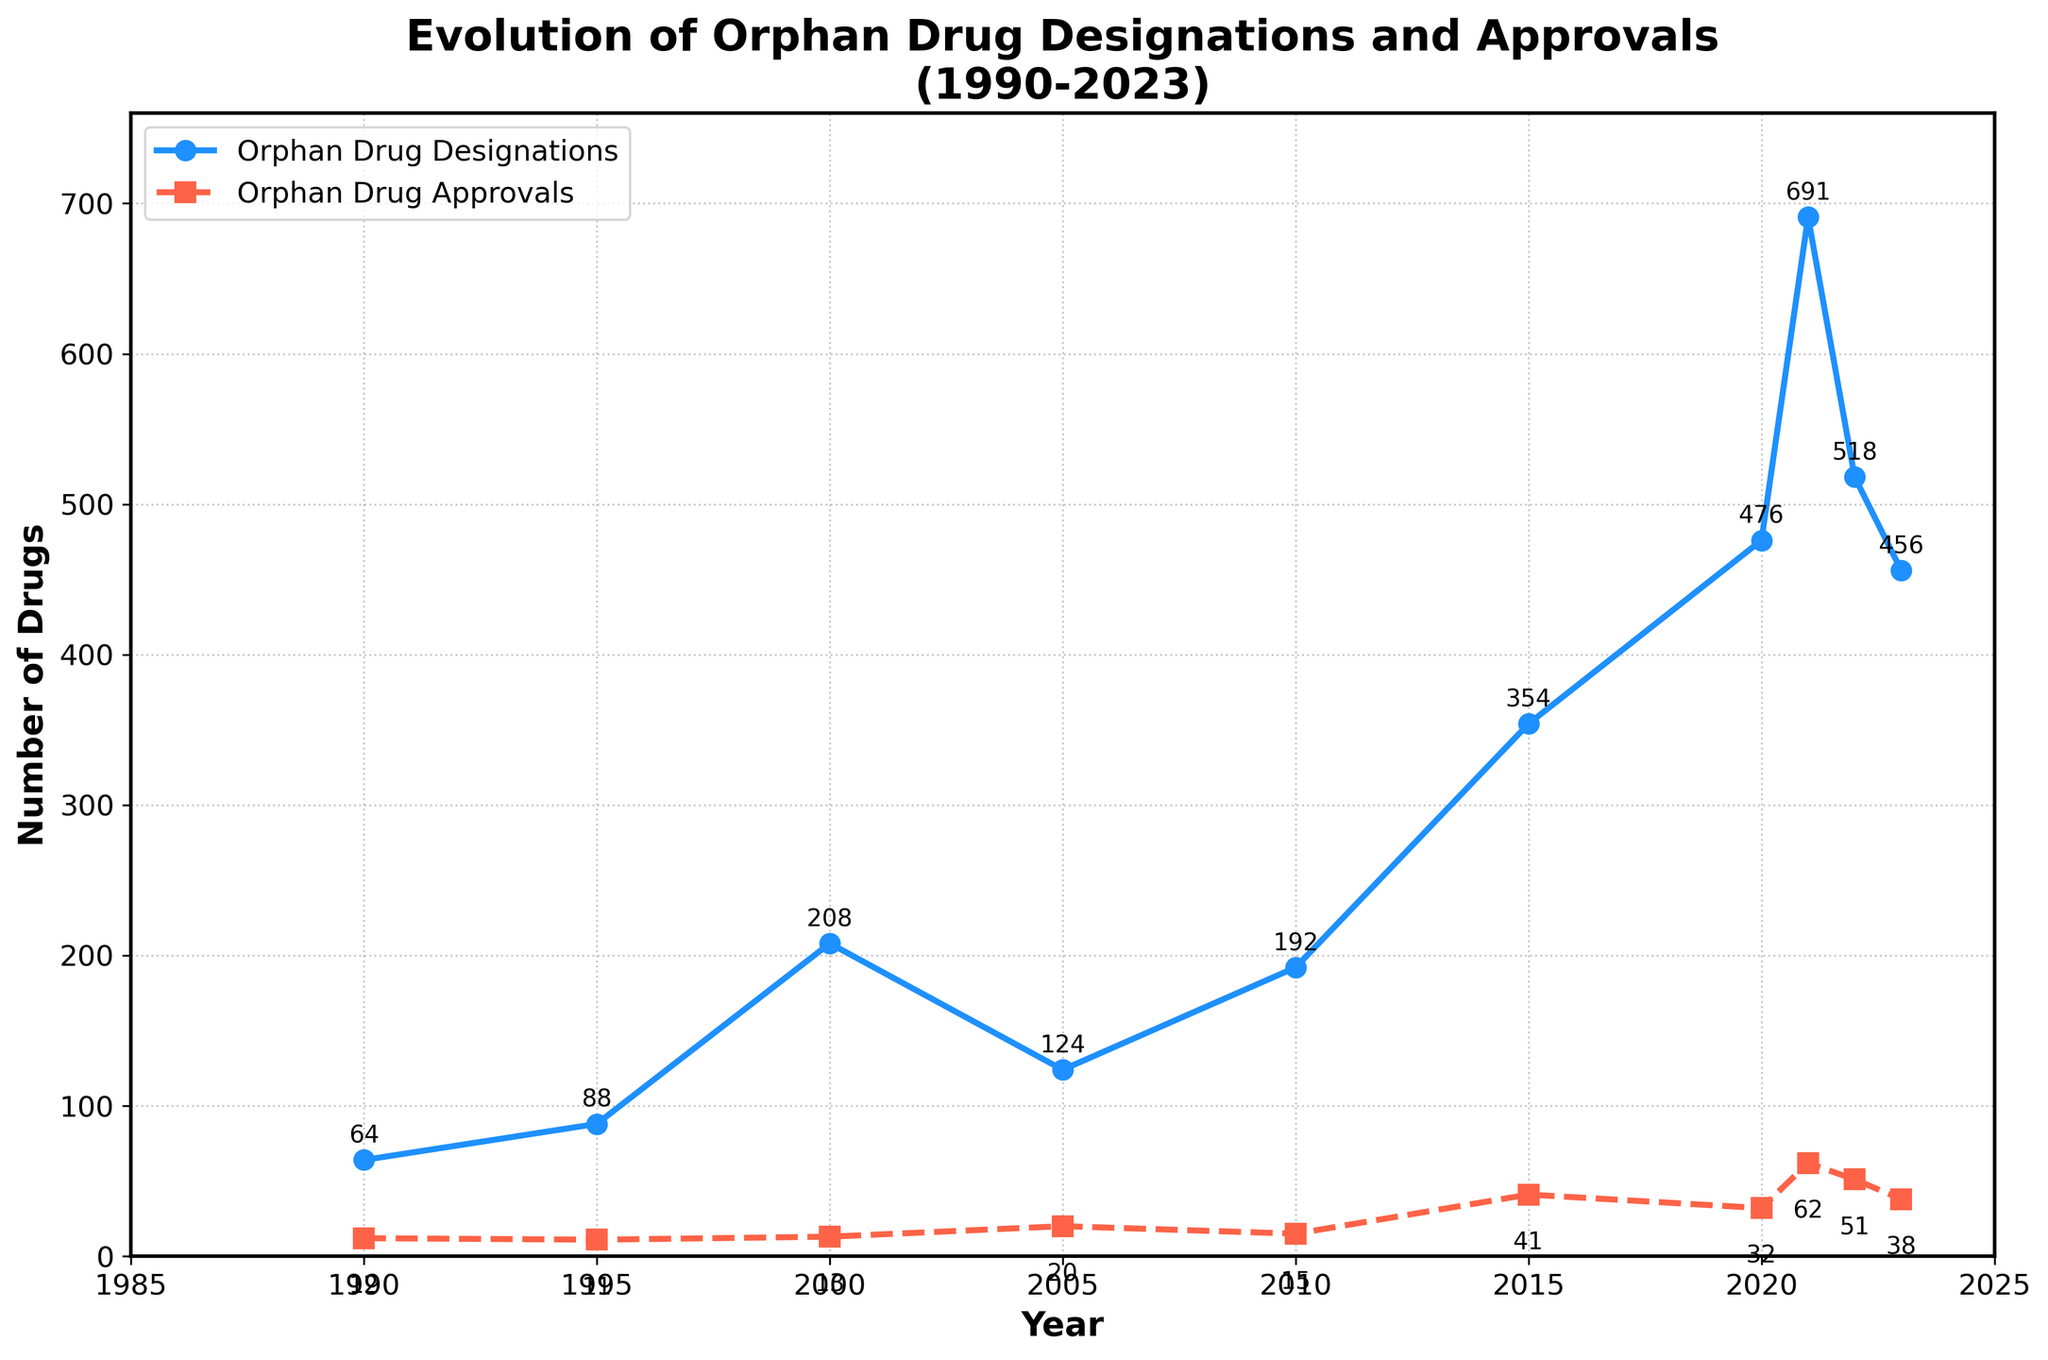How has the number of orphan drug designations changed from 1990 to 2023? To find out the change in the number of designations, look at the designations for 1990 and 2023. In 1990, there were 64 designations, and in 2023, there were 456 designations. The change is 456 - 64 = 392.
Answer: Increased by 392 What is the highest number of orphan drug approvals recorded over the years, and in which year did it occur? Look at the line representing orphan drug approvals and find the highest point. The highest number of approvals is 62, which occurs in 2021.
Answer: 62 in 2021 Compare the trend of orphan drug designations and orphan drug approvals from 2000 to 2023. From 2000 to 2023, orphan drug designations generally increased, with ups and downs, peaking around 2021 and then declining. Orphan drug approvals followed a similar trend, peaking in 2021 as well.
Answer: Both increased, peaking in 2021 Which year shows the largest increase in orphan drug designations compared to the previous year? Calculate the differences year-over-year. The largest increase is between 2020 and 2021, from 476 to 691, which is an increase of 215.
Answer: 2021 What can you infer about the relationship between orphan drug designations and approvals over the last three decades? Observing the trends, there is a general positive correlation; as the number of designations increases, the number of approvals tends to increase. This is particularly noticeable between 2015 and 2021.
Answer: Positive correlation What is the average number of orphan drug designations per decade, starting from 1990? Sum the designations for each decade and divide by the number of years in the decade. For simplicity: 1990-1999 (88+64)/10, 2000-2009 (208+124)/10, 2010-2019 (192+354)/10, 2020-2023 (476+691+518+456)/4. Compute the average of these averages.
Answer: 208.6 What is the difference between the peak number of orphan drug approvals and the peak number of designations? The peak number of approvals is 62, and the peak number of designations is 691. The difference is 691 - 62.
Answer: 629 How did the number of orphan drug approvals in 2020 compare with those in 2015? Look at the approvals for 2015 and 2020. In 2015, there were 41 approvals, and in 2020, there were 32. The number in 2020 was less than in 2015 by 41 - 32 = 9.
Answer: 9 less in 2020 In which years did the number of orphan drug designations exceed 500? Identify years where the number of designations is greater than 500. This occurs in 2020, 2021, and 2022.
Answer: 2020, 2021, 2022 